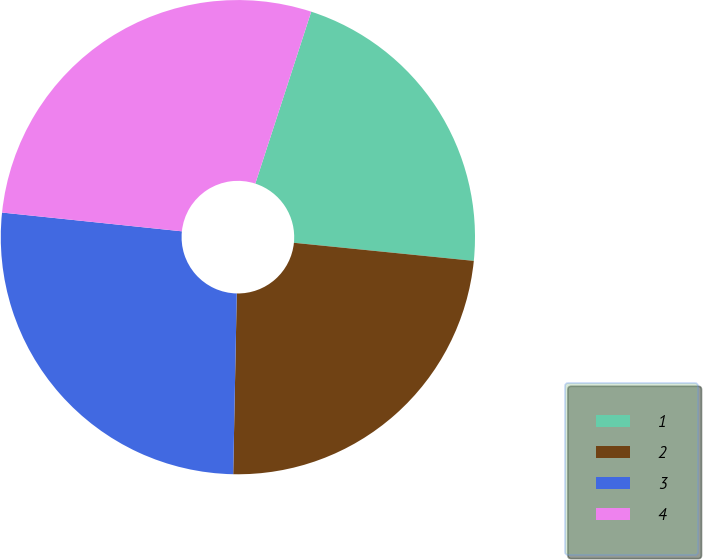Convert chart. <chart><loc_0><loc_0><loc_500><loc_500><pie_chart><fcel>1<fcel>2<fcel>3<fcel>4<nl><fcel>21.59%<fcel>23.72%<fcel>26.34%<fcel>28.35%<nl></chart> 